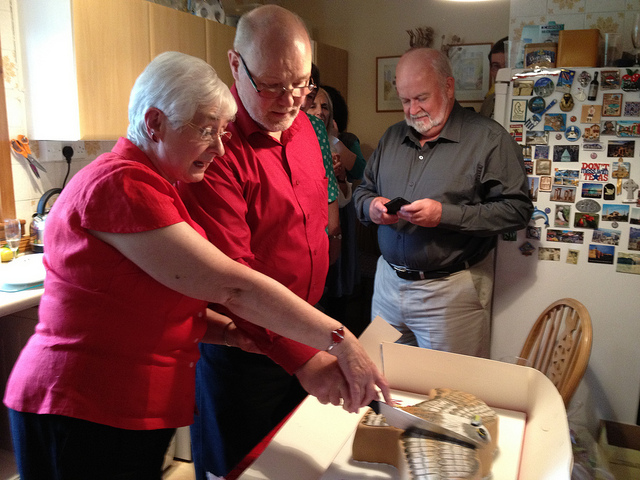Extract all visible text content from this image. DON'T TEXAS 